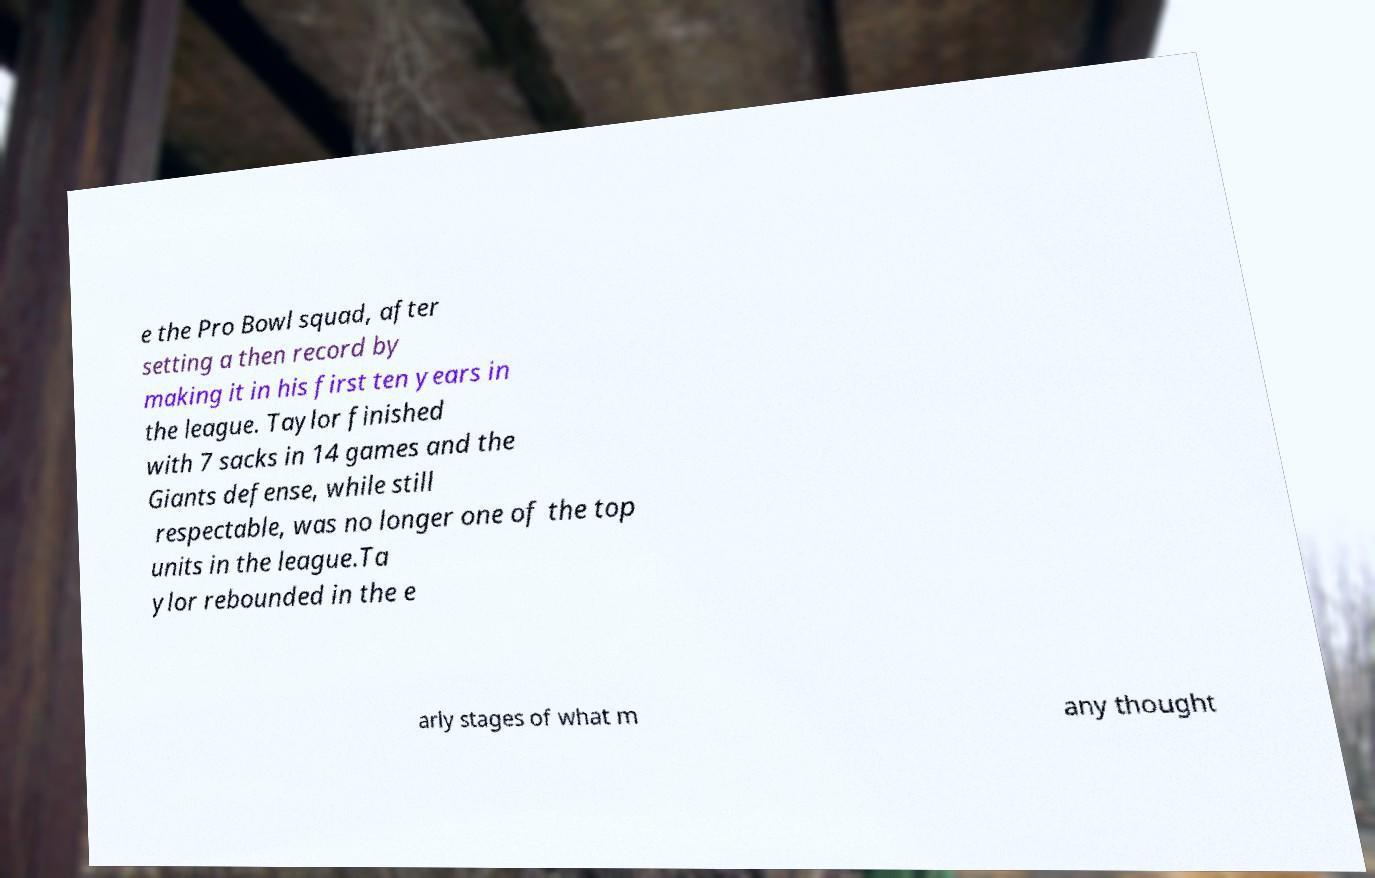Could you extract and type out the text from this image? e the Pro Bowl squad, after setting a then record by making it in his first ten years in the league. Taylor finished with 7 sacks in 14 games and the Giants defense, while still respectable, was no longer one of the top units in the league.Ta ylor rebounded in the e arly stages of what m any thought 